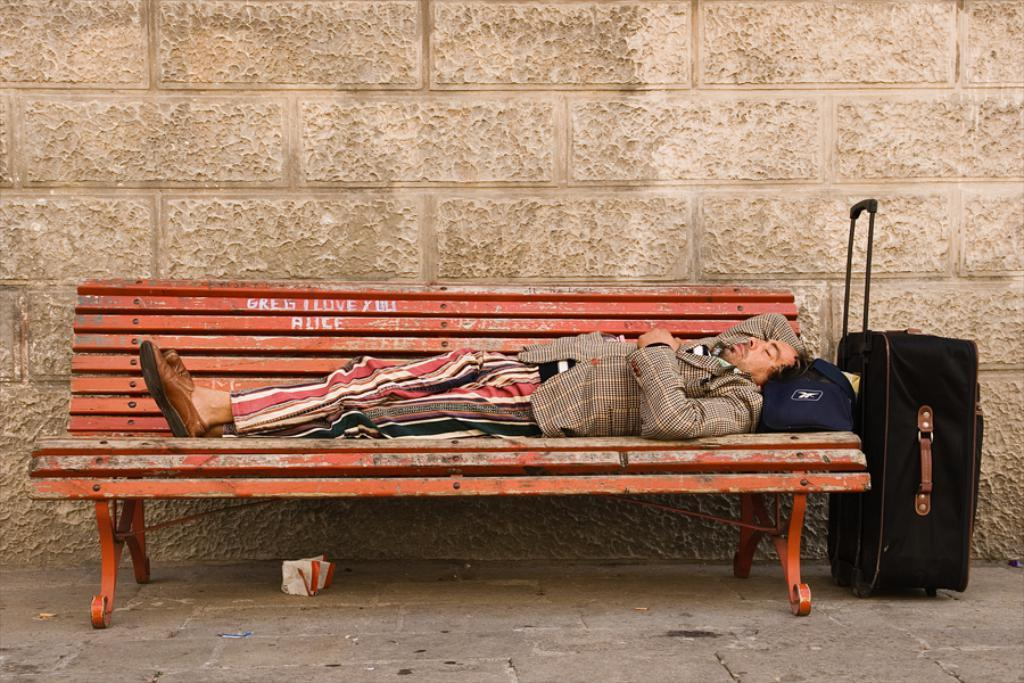Who is present in the image? There is a man in the image. What is the man doing in the image? The man is lying on a bench. What object can be seen in the image besides the man? There is a bag in the image. What can be seen in the background of the image? There is a wall in the background of the image. What language is the man speaking in the image? The image does not provide any information about the man speaking or any language being spoken. 